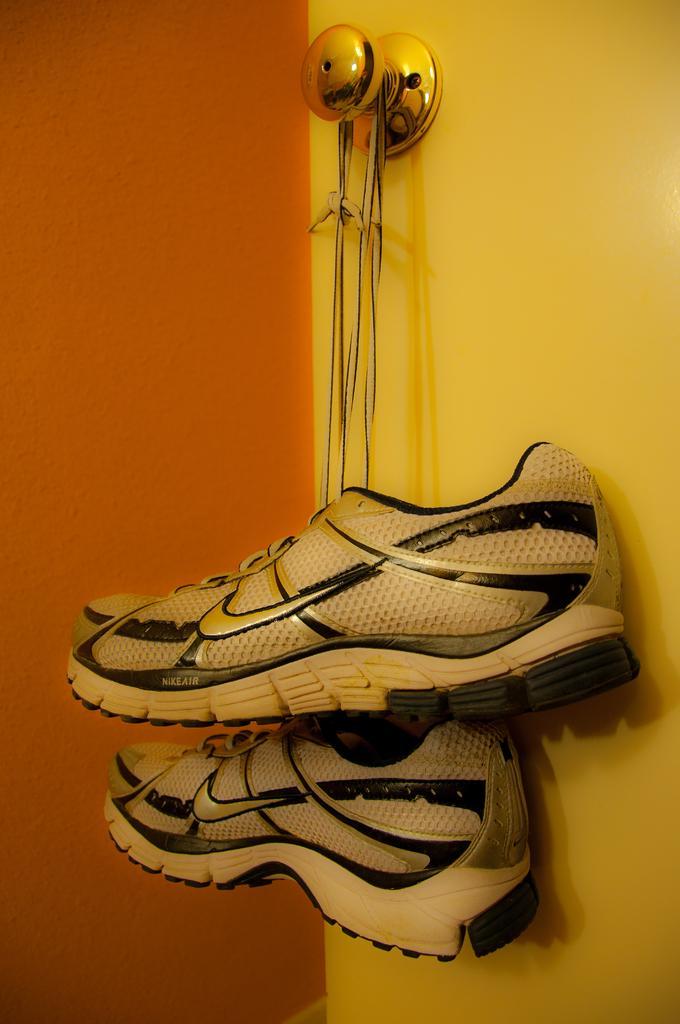In one or two sentences, can you explain what this image depicts? In this image in the center there are a pair of shoes which are hanging to a door, in the background there is a wall. 